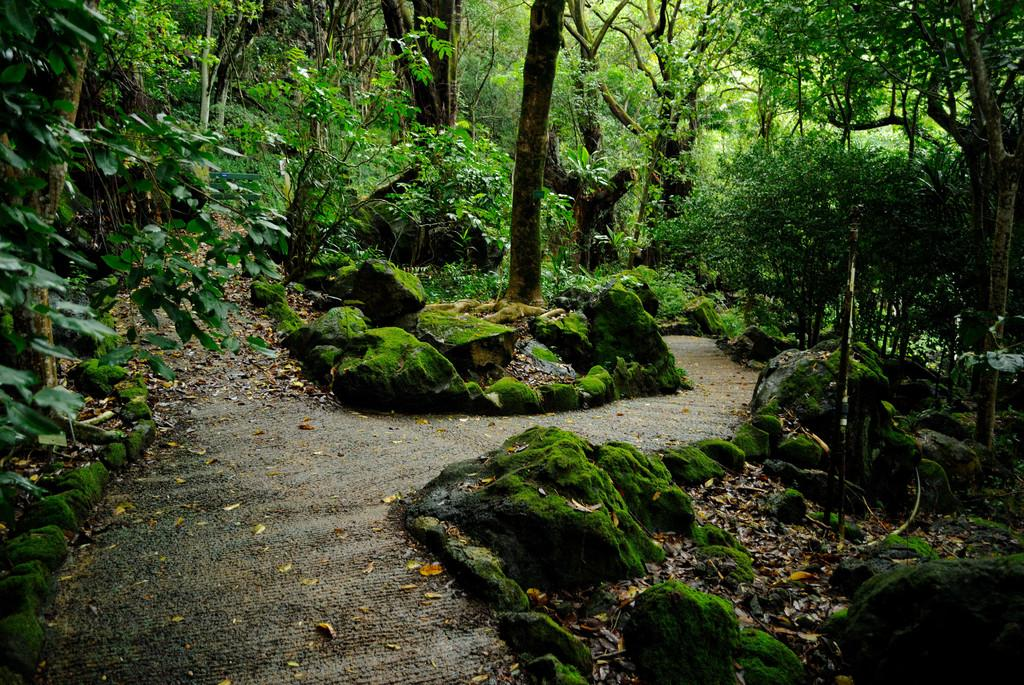What type of natural elements can be seen in the image? There are rocks, trees, and plants in the image. What is covering the ground in the image? Dried leaves are present on the ground in the image. What type of crook can be seen using a hammer to fix the route in the image? There is no crook, hammer, or route present in the image. 